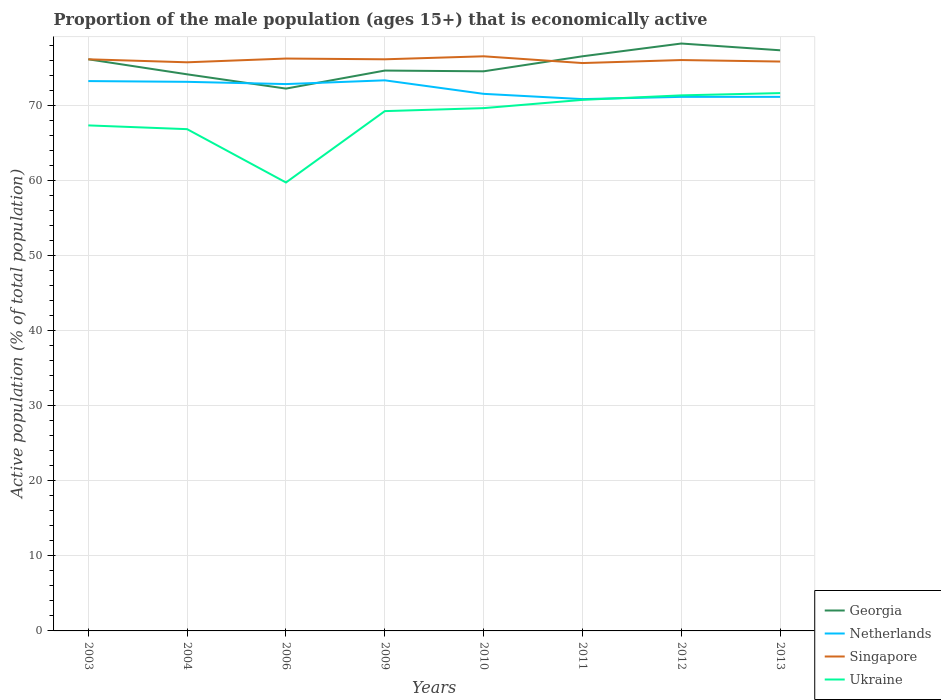How many different coloured lines are there?
Offer a very short reply. 4. Across all years, what is the maximum proportion of the male population that is economically active in Netherlands?
Your response must be concise. 70.8. In which year was the proportion of the male population that is economically active in Netherlands maximum?
Your response must be concise. 2011. What is the total proportion of the male population that is economically active in Singapore in the graph?
Provide a short and direct response. -0.4. What is the difference between the highest and the second highest proportion of the male population that is economically active in Georgia?
Ensure brevity in your answer.  6. What is the difference between the highest and the lowest proportion of the male population that is economically active in Ukraine?
Your answer should be very brief. 5. How many lines are there?
Provide a short and direct response. 4. Does the graph contain grids?
Keep it short and to the point. Yes. How many legend labels are there?
Provide a succinct answer. 4. What is the title of the graph?
Give a very brief answer. Proportion of the male population (ages 15+) that is economically active. Does "Liberia" appear as one of the legend labels in the graph?
Your answer should be compact. No. What is the label or title of the X-axis?
Your answer should be compact. Years. What is the label or title of the Y-axis?
Provide a short and direct response. Active population (% of total population). What is the Active population (% of total population) in Georgia in 2003?
Keep it short and to the point. 76.1. What is the Active population (% of total population) of Netherlands in 2003?
Your response must be concise. 73.2. What is the Active population (% of total population) of Singapore in 2003?
Your response must be concise. 76.1. What is the Active population (% of total population) of Ukraine in 2003?
Offer a terse response. 67.3. What is the Active population (% of total population) of Georgia in 2004?
Offer a terse response. 74.1. What is the Active population (% of total population) of Netherlands in 2004?
Keep it short and to the point. 73.1. What is the Active population (% of total population) in Singapore in 2004?
Make the answer very short. 75.7. What is the Active population (% of total population) of Ukraine in 2004?
Offer a terse response. 66.8. What is the Active population (% of total population) of Georgia in 2006?
Provide a succinct answer. 72.2. What is the Active population (% of total population) in Netherlands in 2006?
Your response must be concise. 72.8. What is the Active population (% of total population) in Singapore in 2006?
Your answer should be very brief. 76.2. What is the Active population (% of total population) of Ukraine in 2006?
Keep it short and to the point. 59.7. What is the Active population (% of total population) in Georgia in 2009?
Your answer should be compact. 74.6. What is the Active population (% of total population) in Netherlands in 2009?
Offer a very short reply. 73.3. What is the Active population (% of total population) in Singapore in 2009?
Offer a very short reply. 76.1. What is the Active population (% of total population) of Ukraine in 2009?
Make the answer very short. 69.2. What is the Active population (% of total population) in Georgia in 2010?
Your answer should be very brief. 74.5. What is the Active population (% of total population) of Netherlands in 2010?
Your response must be concise. 71.5. What is the Active population (% of total population) in Singapore in 2010?
Ensure brevity in your answer.  76.5. What is the Active population (% of total population) of Ukraine in 2010?
Make the answer very short. 69.6. What is the Active population (% of total population) in Georgia in 2011?
Offer a terse response. 76.5. What is the Active population (% of total population) of Netherlands in 2011?
Give a very brief answer. 70.8. What is the Active population (% of total population) of Singapore in 2011?
Provide a succinct answer. 75.6. What is the Active population (% of total population) in Ukraine in 2011?
Your response must be concise. 70.7. What is the Active population (% of total population) of Georgia in 2012?
Give a very brief answer. 78.2. What is the Active population (% of total population) in Netherlands in 2012?
Give a very brief answer. 71.1. What is the Active population (% of total population) of Singapore in 2012?
Give a very brief answer. 76. What is the Active population (% of total population) in Ukraine in 2012?
Give a very brief answer. 71.3. What is the Active population (% of total population) in Georgia in 2013?
Give a very brief answer. 77.3. What is the Active population (% of total population) of Netherlands in 2013?
Offer a terse response. 71.1. What is the Active population (% of total population) of Singapore in 2013?
Make the answer very short. 75.8. What is the Active population (% of total population) of Ukraine in 2013?
Make the answer very short. 71.6. Across all years, what is the maximum Active population (% of total population) of Georgia?
Your answer should be very brief. 78.2. Across all years, what is the maximum Active population (% of total population) in Netherlands?
Your answer should be compact. 73.3. Across all years, what is the maximum Active population (% of total population) in Singapore?
Give a very brief answer. 76.5. Across all years, what is the maximum Active population (% of total population) of Ukraine?
Ensure brevity in your answer.  71.6. Across all years, what is the minimum Active population (% of total population) of Georgia?
Offer a terse response. 72.2. Across all years, what is the minimum Active population (% of total population) in Netherlands?
Offer a terse response. 70.8. Across all years, what is the minimum Active population (% of total population) of Singapore?
Your answer should be compact. 75.6. Across all years, what is the minimum Active population (% of total population) of Ukraine?
Offer a terse response. 59.7. What is the total Active population (% of total population) of Georgia in the graph?
Your answer should be compact. 603.5. What is the total Active population (% of total population) in Netherlands in the graph?
Offer a very short reply. 576.9. What is the total Active population (% of total population) in Singapore in the graph?
Keep it short and to the point. 608. What is the total Active population (% of total population) in Ukraine in the graph?
Ensure brevity in your answer.  546.2. What is the difference between the Active population (% of total population) of Georgia in 2003 and that in 2004?
Your answer should be very brief. 2. What is the difference between the Active population (% of total population) of Netherlands in 2003 and that in 2004?
Ensure brevity in your answer.  0.1. What is the difference between the Active population (% of total population) in Singapore in 2003 and that in 2004?
Ensure brevity in your answer.  0.4. What is the difference between the Active population (% of total population) in Ukraine in 2003 and that in 2004?
Offer a very short reply. 0.5. What is the difference between the Active population (% of total population) of Georgia in 2003 and that in 2006?
Provide a short and direct response. 3.9. What is the difference between the Active population (% of total population) of Singapore in 2003 and that in 2006?
Provide a short and direct response. -0.1. What is the difference between the Active population (% of total population) in Ukraine in 2003 and that in 2006?
Ensure brevity in your answer.  7.6. What is the difference between the Active population (% of total population) in Georgia in 2003 and that in 2009?
Offer a terse response. 1.5. What is the difference between the Active population (% of total population) of Singapore in 2003 and that in 2009?
Your answer should be compact. 0. What is the difference between the Active population (% of total population) in Georgia in 2003 and that in 2010?
Offer a terse response. 1.6. What is the difference between the Active population (% of total population) in Singapore in 2003 and that in 2010?
Offer a very short reply. -0.4. What is the difference between the Active population (% of total population) of Georgia in 2003 and that in 2012?
Provide a succinct answer. -2.1. What is the difference between the Active population (% of total population) in Netherlands in 2003 and that in 2012?
Make the answer very short. 2.1. What is the difference between the Active population (% of total population) of Ukraine in 2003 and that in 2012?
Provide a short and direct response. -4. What is the difference between the Active population (% of total population) of Netherlands in 2003 and that in 2013?
Provide a short and direct response. 2.1. What is the difference between the Active population (% of total population) in Singapore in 2003 and that in 2013?
Ensure brevity in your answer.  0.3. What is the difference between the Active population (% of total population) of Singapore in 2004 and that in 2009?
Ensure brevity in your answer.  -0.4. What is the difference between the Active population (% of total population) of Ukraine in 2004 and that in 2009?
Ensure brevity in your answer.  -2.4. What is the difference between the Active population (% of total population) in Netherlands in 2004 and that in 2010?
Give a very brief answer. 1.6. What is the difference between the Active population (% of total population) of Singapore in 2004 and that in 2010?
Offer a very short reply. -0.8. What is the difference between the Active population (% of total population) in Ukraine in 2004 and that in 2011?
Provide a succinct answer. -3.9. What is the difference between the Active population (% of total population) in Netherlands in 2004 and that in 2012?
Your answer should be very brief. 2. What is the difference between the Active population (% of total population) in Georgia in 2004 and that in 2013?
Give a very brief answer. -3.2. What is the difference between the Active population (% of total population) of Netherlands in 2006 and that in 2010?
Keep it short and to the point. 1.3. What is the difference between the Active population (% of total population) of Netherlands in 2006 and that in 2011?
Offer a very short reply. 2. What is the difference between the Active population (% of total population) in Singapore in 2006 and that in 2011?
Your answer should be compact. 0.6. What is the difference between the Active population (% of total population) in Ukraine in 2006 and that in 2011?
Your answer should be very brief. -11. What is the difference between the Active population (% of total population) of Ukraine in 2006 and that in 2012?
Give a very brief answer. -11.6. What is the difference between the Active population (% of total population) of Georgia in 2006 and that in 2013?
Keep it short and to the point. -5.1. What is the difference between the Active population (% of total population) in Singapore in 2006 and that in 2013?
Your response must be concise. 0.4. What is the difference between the Active population (% of total population) in Georgia in 2009 and that in 2010?
Ensure brevity in your answer.  0.1. What is the difference between the Active population (% of total population) in Ukraine in 2009 and that in 2010?
Provide a succinct answer. -0.4. What is the difference between the Active population (% of total population) in Georgia in 2009 and that in 2011?
Offer a terse response. -1.9. What is the difference between the Active population (% of total population) of Netherlands in 2009 and that in 2011?
Provide a short and direct response. 2.5. What is the difference between the Active population (% of total population) in Singapore in 2009 and that in 2011?
Your answer should be compact. 0.5. What is the difference between the Active population (% of total population) of Georgia in 2009 and that in 2012?
Keep it short and to the point. -3.6. What is the difference between the Active population (% of total population) of Netherlands in 2009 and that in 2012?
Your response must be concise. 2.2. What is the difference between the Active population (% of total population) in Singapore in 2009 and that in 2012?
Keep it short and to the point. 0.1. What is the difference between the Active population (% of total population) in Netherlands in 2009 and that in 2013?
Provide a short and direct response. 2.2. What is the difference between the Active population (% of total population) of Ukraine in 2009 and that in 2013?
Your response must be concise. -2.4. What is the difference between the Active population (% of total population) of Ukraine in 2010 and that in 2011?
Your answer should be compact. -1.1. What is the difference between the Active population (% of total population) in Georgia in 2010 and that in 2012?
Your answer should be very brief. -3.7. What is the difference between the Active population (% of total population) of Singapore in 2010 and that in 2012?
Your answer should be very brief. 0.5. What is the difference between the Active population (% of total population) in Ukraine in 2010 and that in 2012?
Make the answer very short. -1.7. What is the difference between the Active population (% of total population) of Georgia in 2010 and that in 2013?
Your answer should be compact. -2.8. What is the difference between the Active population (% of total population) in Netherlands in 2010 and that in 2013?
Your answer should be compact. 0.4. What is the difference between the Active population (% of total population) of Singapore in 2010 and that in 2013?
Your answer should be compact. 0.7. What is the difference between the Active population (% of total population) in Ukraine in 2010 and that in 2013?
Keep it short and to the point. -2. What is the difference between the Active population (% of total population) in Georgia in 2011 and that in 2012?
Offer a very short reply. -1.7. What is the difference between the Active population (% of total population) in Netherlands in 2011 and that in 2012?
Your answer should be very brief. -0.3. What is the difference between the Active population (% of total population) of Singapore in 2011 and that in 2012?
Provide a short and direct response. -0.4. What is the difference between the Active population (% of total population) of Netherlands in 2012 and that in 2013?
Your answer should be very brief. 0. What is the difference between the Active population (% of total population) in Singapore in 2012 and that in 2013?
Provide a succinct answer. 0.2. What is the difference between the Active population (% of total population) in Georgia in 2003 and the Active population (% of total population) in Singapore in 2004?
Keep it short and to the point. 0.4. What is the difference between the Active population (% of total population) in Georgia in 2003 and the Active population (% of total population) in Ukraine in 2004?
Your response must be concise. 9.3. What is the difference between the Active population (% of total population) in Netherlands in 2003 and the Active population (% of total population) in Ukraine in 2004?
Your answer should be very brief. 6.4. What is the difference between the Active population (% of total population) of Singapore in 2003 and the Active population (% of total population) of Ukraine in 2004?
Your response must be concise. 9.3. What is the difference between the Active population (% of total population) in Georgia in 2003 and the Active population (% of total population) in Singapore in 2006?
Your response must be concise. -0.1. What is the difference between the Active population (% of total population) of Netherlands in 2003 and the Active population (% of total population) of Singapore in 2006?
Offer a very short reply. -3. What is the difference between the Active population (% of total population) of Georgia in 2003 and the Active population (% of total population) of Netherlands in 2009?
Your answer should be compact. 2.8. What is the difference between the Active population (% of total population) of Netherlands in 2003 and the Active population (% of total population) of Singapore in 2009?
Provide a short and direct response. -2.9. What is the difference between the Active population (% of total population) of Netherlands in 2003 and the Active population (% of total population) of Ukraine in 2009?
Your answer should be compact. 4. What is the difference between the Active population (% of total population) of Singapore in 2003 and the Active population (% of total population) of Ukraine in 2009?
Keep it short and to the point. 6.9. What is the difference between the Active population (% of total population) of Georgia in 2003 and the Active population (% of total population) of Netherlands in 2010?
Ensure brevity in your answer.  4.6. What is the difference between the Active population (% of total population) in Georgia in 2003 and the Active population (% of total population) in Singapore in 2010?
Your answer should be very brief. -0.4. What is the difference between the Active population (% of total population) in Netherlands in 2003 and the Active population (% of total population) in Singapore in 2010?
Your answer should be very brief. -3.3. What is the difference between the Active population (% of total population) of Georgia in 2003 and the Active population (% of total population) of Singapore in 2011?
Provide a short and direct response. 0.5. What is the difference between the Active population (% of total population) of Georgia in 2003 and the Active population (% of total population) of Singapore in 2012?
Keep it short and to the point. 0.1. What is the difference between the Active population (% of total population) in Georgia in 2003 and the Active population (% of total population) in Ukraine in 2012?
Offer a very short reply. 4.8. What is the difference between the Active population (% of total population) of Netherlands in 2003 and the Active population (% of total population) of Singapore in 2012?
Your response must be concise. -2.8. What is the difference between the Active population (% of total population) of Singapore in 2003 and the Active population (% of total population) of Ukraine in 2012?
Keep it short and to the point. 4.8. What is the difference between the Active population (% of total population) of Georgia in 2003 and the Active population (% of total population) of Singapore in 2013?
Make the answer very short. 0.3. What is the difference between the Active population (% of total population) in Georgia in 2003 and the Active population (% of total population) in Ukraine in 2013?
Your response must be concise. 4.5. What is the difference between the Active population (% of total population) in Netherlands in 2003 and the Active population (% of total population) in Singapore in 2013?
Provide a succinct answer. -2.6. What is the difference between the Active population (% of total population) in Netherlands in 2003 and the Active population (% of total population) in Ukraine in 2013?
Make the answer very short. 1.6. What is the difference between the Active population (% of total population) in Singapore in 2003 and the Active population (% of total population) in Ukraine in 2013?
Make the answer very short. 4.5. What is the difference between the Active population (% of total population) of Georgia in 2004 and the Active population (% of total population) of Ukraine in 2006?
Provide a short and direct response. 14.4. What is the difference between the Active population (% of total population) of Netherlands in 2004 and the Active population (% of total population) of Ukraine in 2006?
Ensure brevity in your answer.  13.4. What is the difference between the Active population (% of total population) of Singapore in 2004 and the Active population (% of total population) of Ukraine in 2006?
Provide a succinct answer. 16. What is the difference between the Active population (% of total population) of Georgia in 2004 and the Active population (% of total population) of Ukraine in 2009?
Give a very brief answer. 4.9. What is the difference between the Active population (% of total population) of Georgia in 2004 and the Active population (% of total population) of Ukraine in 2010?
Provide a succinct answer. 4.5. What is the difference between the Active population (% of total population) of Netherlands in 2004 and the Active population (% of total population) of Singapore in 2010?
Offer a very short reply. -3.4. What is the difference between the Active population (% of total population) of Georgia in 2004 and the Active population (% of total population) of Ukraine in 2011?
Make the answer very short. 3.4. What is the difference between the Active population (% of total population) in Netherlands in 2004 and the Active population (% of total population) in Singapore in 2011?
Provide a short and direct response. -2.5. What is the difference between the Active population (% of total population) of Singapore in 2004 and the Active population (% of total population) of Ukraine in 2011?
Make the answer very short. 5. What is the difference between the Active population (% of total population) of Netherlands in 2004 and the Active population (% of total population) of Singapore in 2012?
Provide a succinct answer. -2.9. What is the difference between the Active population (% of total population) in Georgia in 2004 and the Active population (% of total population) in Ukraine in 2013?
Provide a succinct answer. 2.5. What is the difference between the Active population (% of total population) in Netherlands in 2004 and the Active population (% of total population) in Ukraine in 2013?
Make the answer very short. 1.5. What is the difference between the Active population (% of total population) of Singapore in 2004 and the Active population (% of total population) of Ukraine in 2013?
Offer a very short reply. 4.1. What is the difference between the Active population (% of total population) in Georgia in 2006 and the Active population (% of total population) in Ukraine in 2009?
Keep it short and to the point. 3. What is the difference between the Active population (% of total population) in Netherlands in 2006 and the Active population (% of total population) in Singapore in 2009?
Offer a very short reply. -3.3. What is the difference between the Active population (% of total population) in Georgia in 2006 and the Active population (% of total population) in Ukraine in 2010?
Your answer should be compact. 2.6. What is the difference between the Active population (% of total population) of Netherlands in 2006 and the Active population (% of total population) of Ukraine in 2010?
Give a very brief answer. 3.2. What is the difference between the Active population (% of total population) of Singapore in 2006 and the Active population (% of total population) of Ukraine in 2010?
Your answer should be compact. 6.6. What is the difference between the Active population (% of total population) in Georgia in 2006 and the Active population (% of total population) in Netherlands in 2011?
Offer a very short reply. 1.4. What is the difference between the Active population (% of total population) in Georgia in 2006 and the Active population (% of total population) in Netherlands in 2012?
Ensure brevity in your answer.  1.1. What is the difference between the Active population (% of total population) in Georgia in 2006 and the Active population (% of total population) in Ukraine in 2012?
Offer a terse response. 0.9. What is the difference between the Active population (% of total population) of Netherlands in 2006 and the Active population (% of total population) of Singapore in 2012?
Your answer should be compact. -3.2. What is the difference between the Active population (% of total population) of Georgia in 2006 and the Active population (% of total population) of Netherlands in 2013?
Offer a very short reply. 1.1. What is the difference between the Active population (% of total population) in Georgia in 2006 and the Active population (% of total population) in Singapore in 2013?
Keep it short and to the point. -3.6. What is the difference between the Active population (% of total population) of Netherlands in 2006 and the Active population (% of total population) of Singapore in 2013?
Ensure brevity in your answer.  -3. What is the difference between the Active population (% of total population) in Georgia in 2009 and the Active population (% of total population) in Netherlands in 2010?
Your response must be concise. 3.1. What is the difference between the Active population (% of total population) in Netherlands in 2009 and the Active population (% of total population) in Singapore in 2010?
Make the answer very short. -3.2. What is the difference between the Active population (% of total population) of Netherlands in 2009 and the Active population (% of total population) of Ukraine in 2010?
Your response must be concise. 3.7. What is the difference between the Active population (% of total population) in Singapore in 2009 and the Active population (% of total population) in Ukraine in 2010?
Keep it short and to the point. 6.5. What is the difference between the Active population (% of total population) in Georgia in 2009 and the Active population (% of total population) in Ukraine in 2011?
Your answer should be very brief. 3.9. What is the difference between the Active population (% of total population) in Netherlands in 2009 and the Active population (% of total population) in Singapore in 2011?
Your answer should be very brief. -2.3. What is the difference between the Active population (% of total population) in Georgia in 2009 and the Active population (% of total population) in Singapore in 2012?
Offer a terse response. -1.4. What is the difference between the Active population (% of total population) of Netherlands in 2009 and the Active population (% of total population) of Ukraine in 2012?
Make the answer very short. 2. What is the difference between the Active population (% of total population) of Georgia in 2009 and the Active population (% of total population) of Singapore in 2013?
Offer a very short reply. -1.2. What is the difference between the Active population (% of total population) of Netherlands in 2009 and the Active population (% of total population) of Singapore in 2013?
Provide a succinct answer. -2.5. What is the difference between the Active population (% of total population) of Georgia in 2010 and the Active population (% of total population) of Ukraine in 2011?
Give a very brief answer. 3.8. What is the difference between the Active population (% of total population) in Georgia in 2010 and the Active population (% of total population) in Ukraine in 2012?
Offer a terse response. 3.2. What is the difference between the Active population (% of total population) in Netherlands in 2010 and the Active population (% of total population) in Singapore in 2012?
Give a very brief answer. -4.5. What is the difference between the Active population (% of total population) of Singapore in 2010 and the Active population (% of total population) of Ukraine in 2012?
Ensure brevity in your answer.  5.2. What is the difference between the Active population (% of total population) in Georgia in 2010 and the Active population (% of total population) in Singapore in 2013?
Provide a succinct answer. -1.3. What is the difference between the Active population (% of total population) of Georgia in 2010 and the Active population (% of total population) of Ukraine in 2013?
Provide a short and direct response. 2.9. What is the difference between the Active population (% of total population) of Netherlands in 2010 and the Active population (% of total population) of Singapore in 2013?
Keep it short and to the point. -4.3. What is the difference between the Active population (% of total population) of Netherlands in 2010 and the Active population (% of total population) of Ukraine in 2013?
Offer a terse response. -0.1. What is the difference between the Active population (% of total population) in Singapore in 2010 and the Active population (% of total population) in Ukraine in 2013?
Your answer should be compact. 4.9. What is the difference between the Active population (% of total population) in Georgia in 2011 and the Active population (% of total population) in Netherlands in 2012?
Provide a succinct answer. 5.4. What is the difference between the Active population (% of total population) in Netherlands in 2011 and the Active population (% of total population) in Singapore in 2012?
Make the answer very short. -5.2. What is the difference between the Active population (% of total population) in Netherlands in 2011 and the Active population (% of total population) in Ukraine in 2012?
Offer a very short reply. -0.5. What is the difference between the Active population (% of total population) of Singapore in 2011 and the Active population (% of total population) of Ukraine in 2012?
Offer a very short reply. 4.3. What is the difference between the Active population (% of total population) in Georgia in 2011 and the Active population (% of total population) in Singapore in 2013?
Provide a succinct answer. 0.7. What is the difference between the Active population (% of total population) in Georgia in 2012 and the Active population (% of total population) in Singapore in 2013?
Provide a succinct answer. 2.4. What is the difference between the Active population (% of total population) in Netherlands in 2012 and the Active population (% of total population) in Singapore in 2013?
Keep it short and to the point. -4.7. What is the difference between the Active population (% of total population) in Singapore in 2012 and the Active population (% of total population) in Ukraine in 2013?
Ensure brevity in your answer.  4.4. What is the average Active population (% of total population) in Georgia per year?
Offer a terse response. 75.44. What is the average Active population (% of total population) in Netherlands per year?
Ensure brevity in your answer.  72.11. What is the average Active population (% of total population) in Ukraine per year?
Your answer should be compact. 68.28. In the year 2003, what is the difference between the Active population (% of total population) of Georgia and Active population (% of total population) of Singapore?
Provide a short and direct response. 0. In the year 2003, what is the difference between the Active population (% of total population) of Georgia and Active population (% of total population) of Ukraine?
Provide a short and direct response. 8.8. In the year 2003, what is the difference between the Active population (% of total population) in Netherlands and Active population (% of total population) in Singapore?
Make the answer very short. -2.9. In the year 2003, what is the difference between the Active population (% of total population) in Netherlands and Active population (% of total population) in Ukraine?
Your response must be concise. 5.9. In the year 2003, what is the difference between the Active population (% of total population) of Singapore and Active population (% of total population) of Ukraine?
Keep it short and to the point. 8.8. In the year 2004, what is the difference between the Active population (% of total population) of Georgia and Active population (% of total population) of Netherlands?
Offer a very short reply. 1. In the year 2004, what is the difference between the Active population (% of total population) of Netherlands and Active population (% of total population) of Ukraine?
Offer a very short reply. 6.3. In the year 2004, what is the difference between the Active population (% of total population) in Singapore and Active population (% of total population) in Ukraine?
Offer a very short reply. 8.9. In the year 2006, what is the difference between the Active population (% of total population) of Georgia and Active population (% of total population) of Singapore?
Make the answer very short. -4. In the year 2006, what is the difference between the Active population (% of total population) in Georgia and Active population (% of total population) in Ukraine?
Make the answer very short. 12.5. In the year 2006, what is the difference between the Active population (% of total population) of Netherlands and Active population (% of total population) of Ukraine?
Provide a succinct answer. 13.1. In the year 2009, what is the difference between the Active population (% of total population) of Georgia and Active population (% of total population) of Ukraine?
Provide a succinct answer. 5.4. In the year 2009, what is the difference between the Active population (% of total population) in Netherlands and Active population (% of total population) in Singapore?
Provide a short and direct response. -2.8. In the year 2009, what is the difference between the Active population (% of total population) of Netherlands and Active population (% of total population) of Ukraine?
Your response must be concise. 4.1. In the year 2009, what is the difference between the Active population (% of total population) of Singapore and Active population (% of total population) of Ukraine?
Your response must be concise. 6.9. In the year 2010, what is the difference between the Active population (% of total population) of Georgia and Active population (% of total population) of Netherlands?
Provide a succinct answer. 3. In the year 2010, what is the difference between the Active population (% of total population) in Netherlands and Active population (% of total population) in Singapore?
Offer a terse response. -5. In the year 2010, what is the difference between the Active population (% of total population) of Netherlands and Active population (% of total population) of Ukraine?
Keep it short and to the point. 1.9. In the year 2010, what is the difference between the Active population (% of total population) in Singapore and Active population (% of total population) in Ukraine?
Your answer should be compact. 6.9. In the year 2011, what is the difference between the Active population (% of total population) in Georgia and Active population (% of total population) in Netherlands?
Provide a succinct answer. 5.7. In the year 2011, what is the difference between the Active population (% of total population) in Georgia and Active population (% of total population) in Singapore?
Your answer should be very brief. 0.9. In the year 2011, what is the difference between the Active population (% of total population) of Georgia and Active population (% of total population) of Ukraine?
Offer a terse response. 5.8. In the year 2011, what is the difference between the Active population (% of total population) in Singapore and Active population (% of total population) in Ukraine?
Your response must be concise. 4.9. In the year 2012, what is the difference between the Active population (% of total population) of Georgia and Active population (% of total population) of Singapore?
Your answer should be compact. 2.2. In the year 2012, what is the difference between the Active population (% of total population) in Georgia and Active population (% of total population) in Ukraine?
Make the answer very short. 6.9. In the year 2012, what is the difference between the Active population (% of total population) in Netherlands and Active population (% of total population) in Ukraine?
Provide a short and direct response. -0.2. In the year 2013, what is the difference between the Active population (% of total population) of Georgia and Active population (% of total population) of Singapore?
Offer a terse response. 1.5. In the year 2013, what is the difference between the Active population (% of total population) of Netherlands and Active population (% of total population) of Singapore?
Keep it short and to the point. -4.7. In the year 2013, what is the difference between the Active population (% of total population) of Netherlands and Active population (% of total population) of Ukraine?
Keep it short and to the point. -0.5. In the year 2013, what is the difference between the Active population (% of total population) in Singapore and Active population (% of total population) in Ukraine?
Offer a very short reply. 4.2. What is the ratio of the Active population (% of total population) in Ukraine in 2003 to that in 2004?
Make the answer very short. 1.01. What is the ratio of the Active population (% of total population) in Georgia in 2003 to that in 2006?
Keep it short and to the point. 1.05. What is the ratio of the Active population (% of total population) in Netherlands in 2003 to that in 2006?
Offer a terse response. 1.01. What is the ratio of the Active population (% of total population) in Singapore in 2003 to that in 2006?
Offer a very short reply. 1. What is the ratio of the Active population (% of total population) of Ukraine in 2003 to that in 2006?
Ensure brevity in your answer.  1.13. What is the ratio of the Active population (% of total population) of Georgia in 2003 to that in 2009?
Make the answer very short. 1.02. What is the ratio of the Active population (% of total population) of Ukraine in 2003 to that in 2009?
Your answer should be very brief. 0.97. What is the ratio of the Active population (% of total population) of Georgia in 2003 to that in 2010?
Ensure brevity in your answer.  1.02. What is the ratio of the Active population (% of total population) of Netherlands in 2003 to that in 2010?
Ensure brevity in your answer.  1.02. What is the ratio of the Active population (% of total population) in Singapore in 2003 to that in 2010?
Your answer should be compact. 0.99. What is the ratio of the Active population (% of total population) in Ukraine in 2003 to that in 2010?
Your answer should be compact. 0.97. What is the ratio of the Active population (% of total population) in Georgia in 2003 to that in 2011?
Make the answer very short. 0.99. What is the ratio of the Active population (% of total population) of Netherlands in 2003 to that in 2011?
Give a very brief answer. 1.03. What is the ratio of the Active population (% of total population) in Singapore in 2003 to that in 2011?
Offer a very short reply. 1.01. What is the ratio of the Active population (% of total population) of Ukraine in 2003 to that in 2011?
Keep it short and to the point. 0.95. What is the ratio of the Active population (% of total population) in Georgia in 2003 to that in 2012?
Your response must be concise. 0.97. What is the ratio of the Active population (% of total population) of Netherlands in 2003 to that in 2012?
Your response must be concise. 1.03. What is the ratio of the Active population (% of total population) of Singapore in 2003 to that in 2012?
Make the answer very short. 1. What is the ratio of the Active population (% of total population) in Ukraine in 2003 to that in 2012?
Give a very brief answer. 0.94. What is the ratio of the Active population (% of total population) of Georgia in 2003 to that in 2013?
Offer a terse response. 0.98. What is the ratio of the Active population (% of total population) in Netherlands in 2003 to that in 2013?
Your answer should be compact. 1.03. What is the ratio of the Active population (% of total population) of Ukraine in 2003 to that in 2013?
Your response must be concise. 0.94. What is the ratio of the Active population (% of total population) of Georgia in 2004 to that in 2006?
Offer a terse response. 1.03. What is the ratio of the Active population (% of total population) of Netherlands in 2004 to that in 2006?
Offer a terse response. 1. What is the ratio of the Active population (% of total population) of Ukraine in 2004 to that in 2006?
Provide a succinct answer. 1.12. What is the ratio of the Active population (% of total population) in Singapore in 2004 to that in 2009?
Offer a terse response. 0.99. What is the ratio of the Active population (% of total population) in Ukraine in 2004 to that in 2009?
Offer a terse response. 0.97. What is the ratio of the Active population (% of total population) in Netherlands in 2004 to that in 2010?
Offer a very short reply. 1.02. What is the ratio of the Active population (% of total population) in Singapore in 2004 to that in 2010?
Your answer should be compact. 0.99. What is the ratio of the Active population (% of total population) of Ukraine in 2004 to that in 2010?
Your answer should be very brief. 0.96. What is the ratio of the Active population (% of total population) in Georgia in 2004 to that in 2011?
Your answer should be very brief. 0.97. What is the ratio of the Active population (% of total population) of Netherlands in 2004 to that in 2011?
Provide a short and direct response. 1.03. What is the ratio of the Active population (% of total population) of Ukraine in 2004 to that in 2011?
Offer a terse response. 0.94. What is the ratio of the Active population (% of total population) in Georgia in 2004 to that in 2012?
Your answer should be compact. 0.95. What is the ratio of the Active population (% of total population) in Netherlands in 2004 to that in 2012?
Provide a short and direct response. 1.03. What is the ratio of the Active population (% of total population) in Ukraine in 2004 to that in 2012?
Keep it short and to the point. 0.94. What is the ratio of the Active population (% of total population) in Georgia in 2004 to that in 2013?
Your answer should be compact. 0.96. What is the ratio of the Active population (% of total population) in Netherlands in 2004 to that in 2013?
Offer a very short reply. 1.03. What is the ratio of the Active population (% of total population) of Ukraine in 2004 to that in 2013?
Make the answer very short. 0.93. What is the ratio of the Active population (% of total population) in Georgia in 2006 to that in 2009?
Your answer should be very brief. 0.97. What is the ratio of the Active population (% of total population) in Netherlands in 2006 to that in 2009?
Give a very brief answer. 0.99. What is the ratio of the Active population (% of total population) of Ukraine in 2006 to that in 2009?
Provide a succinct answer. 0.86. What is the ratio of the Active population (% of total population) of Georgia in 2006 to that in 2010?
Give a very brief answer. 0.97. What is the ratio of the Active population (% of total population) in Netherlands in 2006 to that in 2010?
Offer a terse response. 1.02. What is the ratio of the Active population (% of total population) of Singapore in 2006 to that in 2010?
Your response must be concise. 1. What is the ratio of the Active population (% of total population) of Ukraine in 2006 to that in 2010?
Make the answer very short. 0.86. What is the ratio of the Active population (% of total population) of Georgia in 2006 to that in 2011?
Offer a terse response. 0.94. What is the ratio of the Active population (% of total population) of Netherlands in 2006 to that in 2011?
Provide a short and direct response. 1.03. What is the ratio of the Active population (% of total population) in Singapore in 2006 to that in 2011?
Offer a terse response. 1.01. What is the ratio of the Active population (% of total population) in Ukraine in 2006 to that in 2011?
Give a very brief answer. 0.84. What is the ratio of the Active population (% of total population) in Georgia in 2006 to that in 2012?
Make the answer very short. 0.92. What is the ratio of the Active population (% of total population) in Netherlands in 2006 to that in 2012?
Make the answer very short. 1.02. What is the ratio of the Active population (% of total population) of Singapore in 2006 to that in 2012?
Your response must be concise. 1. What is the ratio of the Active population (% of total population) of Ukraine in 2006 to that in 2012?
Give a very brief answer. 0.84. What is the ratio of the Active population (% of total population) of Georgia in 2006 to that in 2013?
Ensure brevity in your answer.  0.93. What is the ratio of the Active population (% of total population) in Netherlands in 2006 to that in 2013?
Ensure brevity in your answer.  1.02. What is the ratio of the Active population (% of total population) in Ukraine in 2006 to that in 2013?
Ensure brevity in your answer.  0.83. What is the ratio of the Active population (% of total population) of Netherlands in 2009 to that in 2010?
Give a very brief answer. 1.03. What is the ratio of the Active population (% of total population) in Georgia in 2009 to that in 2011?
Ensure brevity in your answer.  0.98. What is the ratio of the Active population (% of total population) of Netherlands in 2009 to that in 2011?
Offer a very short reply. 1.04. What is the ratio of the Active population (% of total population) of Singapore in 2009 to that in 2011?
Provide a succinct answer. 1.01. What is the ratio of the Active population (% of total population) of Ukraine in 2009 to that in 2011?
Keep it short and to the point. 0.98. What is the ratio of the Active population (% of total population) in Georgia in 2009 to that in 2012?
Your answer should be very brief. 0.95. What is the ratio of the Active population (% of total population) of Netherlands in 2009 to that in 2012?
Your response must be concise. 1.03. What is the ratio of the Active population (% of total population) of Ukraine in 2009 to that in 2012?
Your answer should be compact. 0.97. What is the ratio of the Active population (% of total population) in Georgia in 2009 to that in 2013?
Offer a very short reply. 0.97. What is the ratio of the Active population (% of total population) of Netherlands in 2009 to that in 2013?
Keep it short and to the point. 1.03. What is the ratio of the Active population (% of total population) in Singapore in 2009 to that in 2013?
Keep it short and to the point. 1. What is the ratio of the Active population (% of total population) of Ukraine in 2009 to that in 2013?
Offer a terse response. 0.97. What is the ratio of the Active population (% of total population) in Georgia in 2010 to that in 2011?
Keep it short and to the point. 0.97. What is the ratio of the Active population (% of total population) of Netherlands in 2010 to that in 2011?
Provide a succinct answer. 1.01. What is the ratio of the Active population (% of total population) in Singapore in 2010 to that in 2011?
Your answer should be compact. 1.01. What is the ratio of the Active population (% of total population) in Ukraine in 2010 to that in 2011?
Ensure brevity in your answer.  0.98. What is the ratio of the Active population (% of total population) in Georgia in 2010 to that in 2012?
Provide a succinct answer. 0.95. What is the ratio of the Active population (% of total population) in Netherlands in 2010 to that in 2012?
Give a very brief answer. 1.01. What is the ratio of the Active population (% of total population) of Singapore in 2010 to that in 2012?
Make the answer very short. 1.01. What is the ratio of the Active population (% of total population) of Ukraine in 2010 to that in 2012?
Your answer should be very brief. 0.98. What is the ratio of the Active population (% of total population) of Georgia in 2010 to that in 2013?
Offer a very short reply. 0.96. What is the ratio of the Active population (% of total population) in Netherlands in 2010 to that in 2013?
Provide a short and direct response. 1.01. What is the ratio of the Active population (% of total population) of Singapore in 2010 to that in 2013?
Your answer should be compact. 1.01. What is the ratio of the Active population (% of total population) of Ukraine in 2010 to that in 2013?
Your response must be concise. 0.97. What is the ratio of the Active population (% of total population) in Georgia in 2011 to that in 2012?
Provide a short and direct response. 0.98. What is the ratio of the Active population (% of total population) of Netherlands in 2011 to that in 2012?
Offer a terse response. 1. What is the ratio of the Active population (% of total population) in Singapore in 2011 to that in 2012?
Your answer should be very brief. 0.99. What is the ratio of the Active population (% of total population) of Georgia in 2011 to that in 2013?
Your answer should be very brief. 0.99. What is the ratio of the Active population (% of total population) in Netherlands in 2011 to that in 2013?
Offer a terse response. 1. What is the ratio of the Active population (% of total population) of Singapore in 2011 to that in 2013?
Make the answer very short. 1. What is the ratio of the Active population (% of total population) of Ukraine in 2011 to that in 2013?
Provide a short and direct response. 0.99. What is the ratio of the Active population (% of total population) of Georgia in 2012 to that in 2013?
Keep it short and to the point. 1.01. What is the ratio of the Active population (% of total population) in Netherlands in 2012 to that in 2013?
Provide a short and direct response. 1. What is the ratio of the Active population (% of total population) in Singapore in 2012 to that in 2013?
Your answer should be very brief. 1. What is the ratio of the Active population (% of total population) in Ukraine in 2012 to that in 2013?
Offer a terse response. 1. What is the difference between the highest and the second highest Active population (% of total population) in Georgia?
Give a very brief answer. 0.9. What is the difference between the highest and the second highest Active population (% of total population) in Netherlands?
Give a very brief answer. 0.1. What is the difference between the highest and the second highest Active population (% of total population) of Ukraine?
Offer a terse response. 0.3. What is the difference between the highest and the lowest Active population (% of total population) in Georgia?
Provide a succinct answer. 6. 